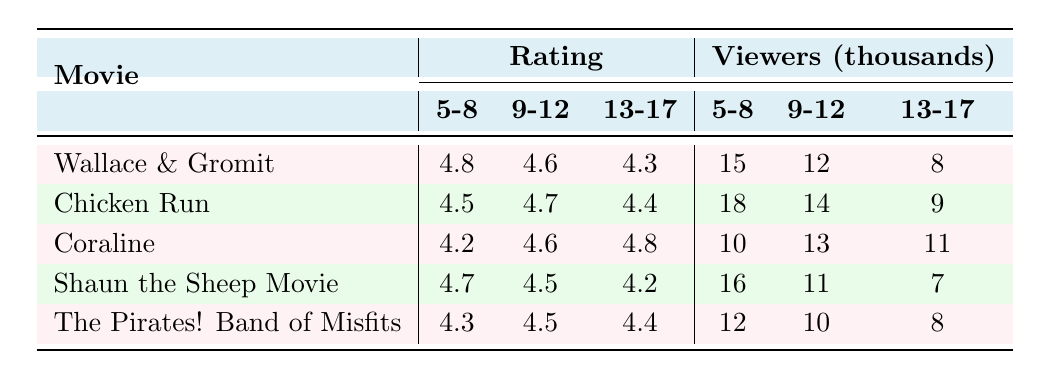What is the rating for "Shaun the Sheep Movie" in the 9-12 age group? The table shows that the rating for "Shaun the Sheep Movie" in the 9-12 age group is listed under that specific row and column, which indicates it is 4.5.
Answer: 4.5 Which movie received the highest rating from ages 5-8? In the 5-8 age group, the ratings for the movies are: Wallace & Gromit (4.8), Chicken Run (4.5), Coraline (4.2), Shaun the Sheep Movie (4.7), and The Pirates! Band of Misfits (4.3). The highest rating is 4.8 for "Wallace & Gromit: The Curse of the Were-Rabbit."
Answer: Wallace & Gromit: The Curse of the Were-Rabbit How many viewers did "Chicken Run" have in the 5-8 age group? The table lists the viewers for "Chicken Run" in the 5-8 age group as 18,000. This value is found in the corresponding row and column for that movie and age group.
Answer: 18,000 Is the rating for "Coraline" in the 13-17 age group higher than 4.5? The rating for "Coraline" in the 13-17 age group is 4.8, which is indeed higher than 4.5. Therefore, the statement is true.
Answer: Yes What is the average rating of the movies for the 9-12 age group? The ratings for the 9-12 age group are: Wallace & Gromit (4.6), Chicken Run (4.7), Coraline (4.6), Shaun the Sheep Movie (4.5), and The Pirates! Band of Misfits (4.5). To find the average, we sum these ratings: 4.6 + 4.7 + 4.6 + 4.5 + 4.5 = 23.9, then divide by 5: 23.9 / 5 = 4.78.
Answer: 4.78 How many total viewers did all the movies combined have in the 13-17 age group? The number of viewers for each movie in the 13-17 age group is: Wallace & Gromit (8,000), Chicken Run (9,000), Coraline (11,000), Shaun the Sheep Movie (7,000), and The Pirates! Band of Misfits (8,000). Adding these together gives: 8 + 9 + 11 + 7 + 8 = 43 (in thousands).
Answer: 43,000 Which movie has the lowest viewer count for the 9-12 age group? The viewer counts for the 9-12 age group are: Wallace & Gromit (12,000), Chicken Run (14,000), Coraline (13,000), Shaun the Sheep Movie (11,000), and The Pirates! Band of Misfits (10,000). The lowest count is 10,000 for "The Pirates! Band of Misfits."
Answer: The Pirates! Band of Misfits Are there more viewers in the 5-8 age group compared to the 13-17 age group across all movies? For the 5-8 age group, the total viewers from all movies are: Wallace & Gromit (15), Chicken Run (18), Coraline (10), Shaun the Sheep Movie (16), and The Pirates! Band of Misfits (12), which sums to 71. For the 13-17 age group, the totals are Wallace & Gromit (8), Chicken Run (9), Coraline (11), Shaun the Sheep Movie (7), and The Pirates! Band of Misfits (8), summing to 43. Since 71 > 43, the answer is yes.
Answer: Yes 